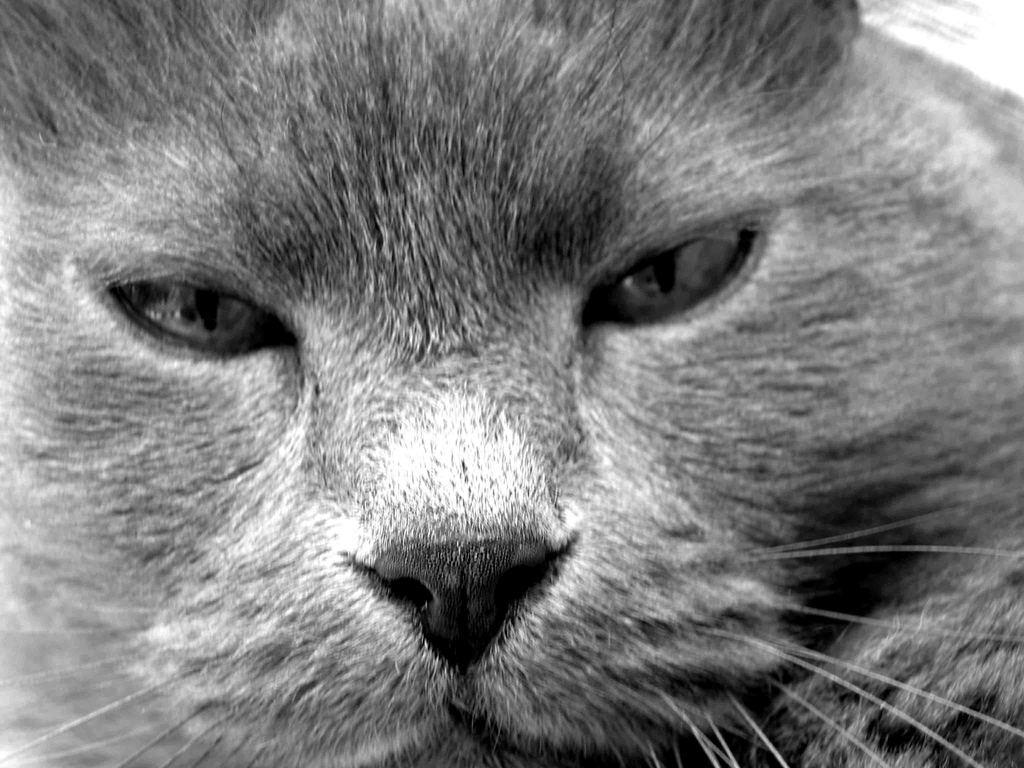What is the color scheme of the image? The image is black and white. What type of subject can be seen in the image? There is an animal in the image. What degree does the goat have in the image? There is no goat present in the image, and therefore no degree can be associated with it. 